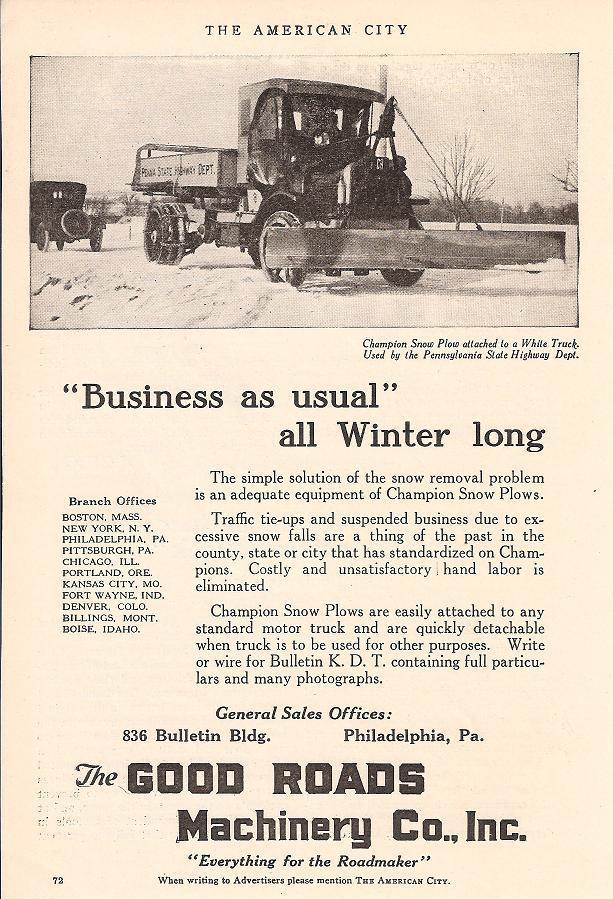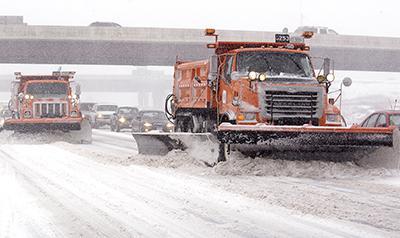The first image is the image on the left, the second image is the image on the right. Assess this claim about the two images: "The left image shows an unattached yellow snow plow with its back side facing the camera.". Correct or not? Answer yes or no. No. 